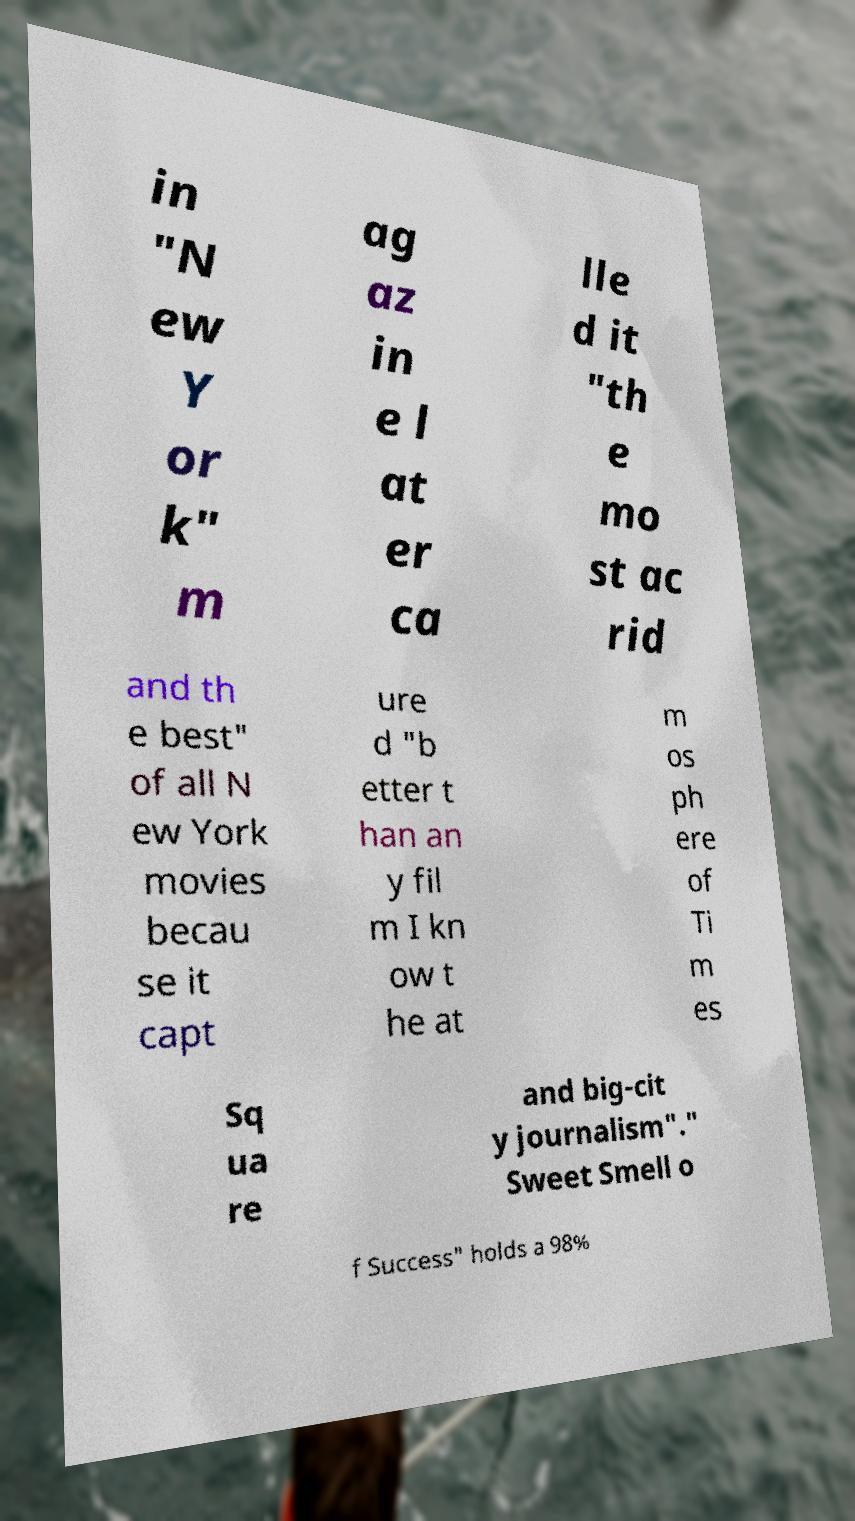Can you read and provide the text displayed in the image?This photo seems to have some interesting text. Can you extract and type it out for me? in "N ew Y or k" m ag az in e l at er ca lle d it "th e mo st ac rid and th e best" of all N ew York movies becau se it capt ure d "b etter t han an y fil m I kn ow t he at m os ph ere of Ti m es Sq ua re and big-cit y journalism"." Sweet Smell o f Success" holds a 98% 